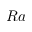Convert formula to latex. <formula><loc_0><loc_0><loc_500><loc_500>R a</formula> 